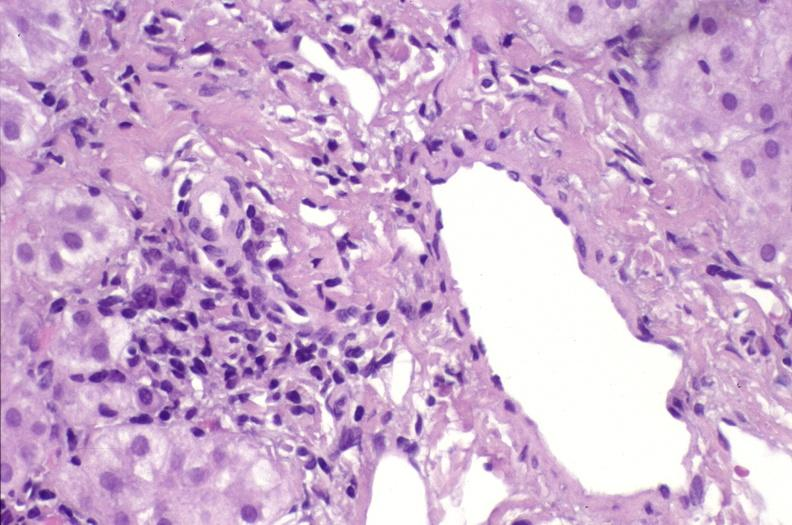does this image show ductopenia?
Answer the question using a single word or phrase. Yes 